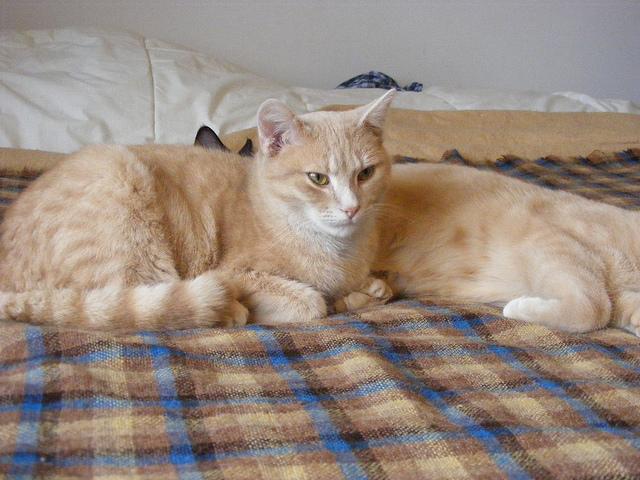How many cats are on the bed?
Concise answer only. 2. What kind of animal can be seen?
Concise answer only. Cat. What type of bedding are the animals in?
Concise answer only. Blanket. What is the pattern on the blanket?
Keep it brief. Plaid. What kind of animals are these?
Quick response, please. Cats. What type of animals are they?
Quick response, please. Cats. Are both cats the same color?
Short answer required. Yes. How many cats are in the picture?
Keep it brief. 2. Is the cat awake?
Be succinct. Yes. 